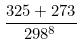Convert formula to latex. <formula><loc_0><loc_0><loc_500><loc_500>\frac { 3 2 5 + 2 7 3 } { 2 9 8 ^ { 8 } }</formula> 